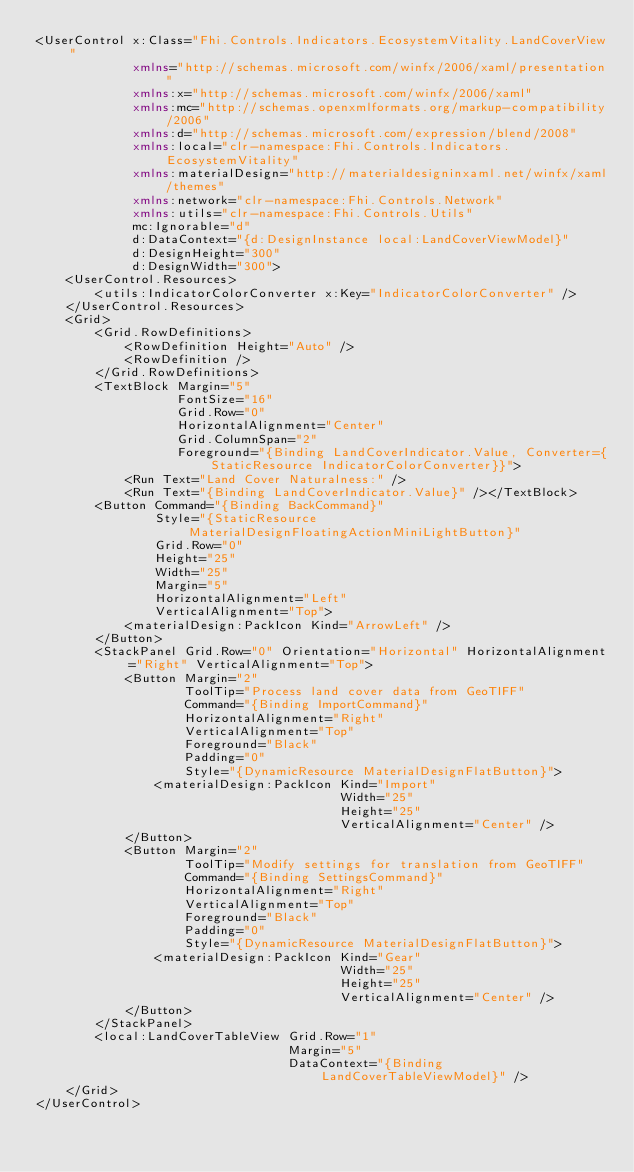<code> <loc_0><loc_0><loc_500><loc_500><_XML_><UserControl x:Class="Fhi.Controls.Indicators.EcosystemVitality.LandCoverView"
             xmlns="http://schemas.microsoft.com/winfx/2006/xaml/presentation"
             xmlns:x="http://schemas.microsoft.com/winfx/2006/xaml"
             xmlns:mc="http://schemas.openxmlformats.org/markup-compatibility/2006"
             xmlns:d="http://schemas.microsoft.com/expression/blend/2008"
             xmlns:local="clr-namespace:Fhi.Controls.Indicators.EcosystemVitality"
             xmlns:materialDesign="http://materialdesigninxaml.net/winfx/xaml/themes"
             xmlns:network="clr-namespace:Fhi.Controls.Network"
             xmlns:utils="clr-namespace:Fhi.Controls.Utils"
             mc:Ignorable="d"
             d:DataContext="{d:DesignInstance local:LandCoverViewModel}"
             d:DesignHeight="300"
             d:DesignWidth="300">
    <UserControl.Resources>
        <utils:IndicatorColorConverter x:Key="IndicatorColorConverter" />
    </UserControl.Resources>
    <Grid>
        <Grid.RowDefinitions>
            <RowDefinition Height="Auto" />
            <RowDefinition />
        </Grid.RowDefinitions>
        <TextBlock Margin="5"
                   FontSize="16"
                   Grid.Row="0"
                   HorizontalAlignment="Center"
                   Grid.ColumnSpan="2"
                   Foreground="{Binding LandCoverIndicator.Value, Converter={StaticResource IndicatorColorConverter}}">
            <Run Text="Land Cover Naturalness:" />
            <Run Text="{Binding LandCoverIndicator.Value}" /></TextBlock>
        <Button Command="{Binding BackCommand}"
                Style="{StaticResource MaterialDesignFloatingActionMiniLightButton}"
                Grid.Row="0"
                Height="25"
                Width="25"
                Margin="5"
                HorizontalAlignment="Left"
                VerticalAlignment="Top">
            <materialDesign:PackIcon Kind="ArrowLeft" />
        </Button>
        <StackPanel Grid.Row="0" Orientation="Horizontal" HorizontalAlignment="Right" VerticalAlignment="Top">
            <Button Margin="2"
                    ToolTip="Process land cover data from GeoTIFF"
                    Command="{Binding ImportCommand}"
                    HorizontalAlignment="Right"
                    VerticalAlignment="Top"
                    Foreground="Black"
                    Padding="0"
                    Style="{DynamicResource MaterialDesignFlatButton}">
                <materialDesign:PackIcon Kind="Import"
                                         Width="25"
                                         Height="25"
                                         VerticalAlignment="Center" />
            </Button>
            <Button Margin="2"
                    ToolTip="Modify settings for translation from GeoTIFF"
                    Command="{Binding SettingsCommand}"
                    HorizontalAlignment="Right"
                    VerticalAlignment="Top"
                    Foreground="Black"
                    Padding="0"
                    Style="{DynamicResource MaterialDesignFlatButton}">
                <materialDesign:PackIcon Kind="Gear"
                                         Width="25"
                                         Height="25"
                                         VerticalAlignment="Center" />
            </Button>
        </StackPanel>
        <local:LandCoverTableView Grid.Row="1"
                                  Margin="5"
                                  DataContext="{Binding LandCoverTableViewModel}" />
    </Grid>
</UserControl>
</code> 